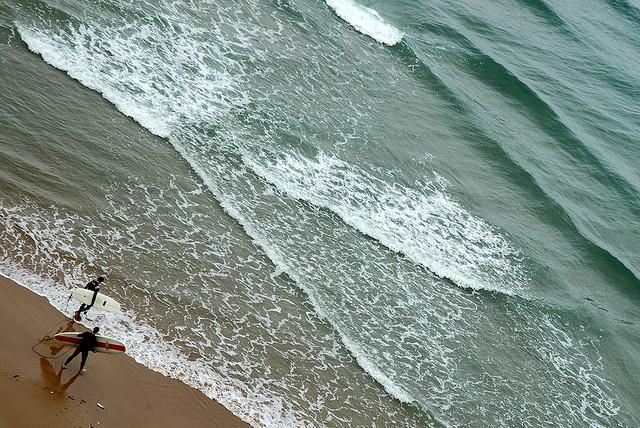How many people are going surfing?
Give a very brief answer. 2. 